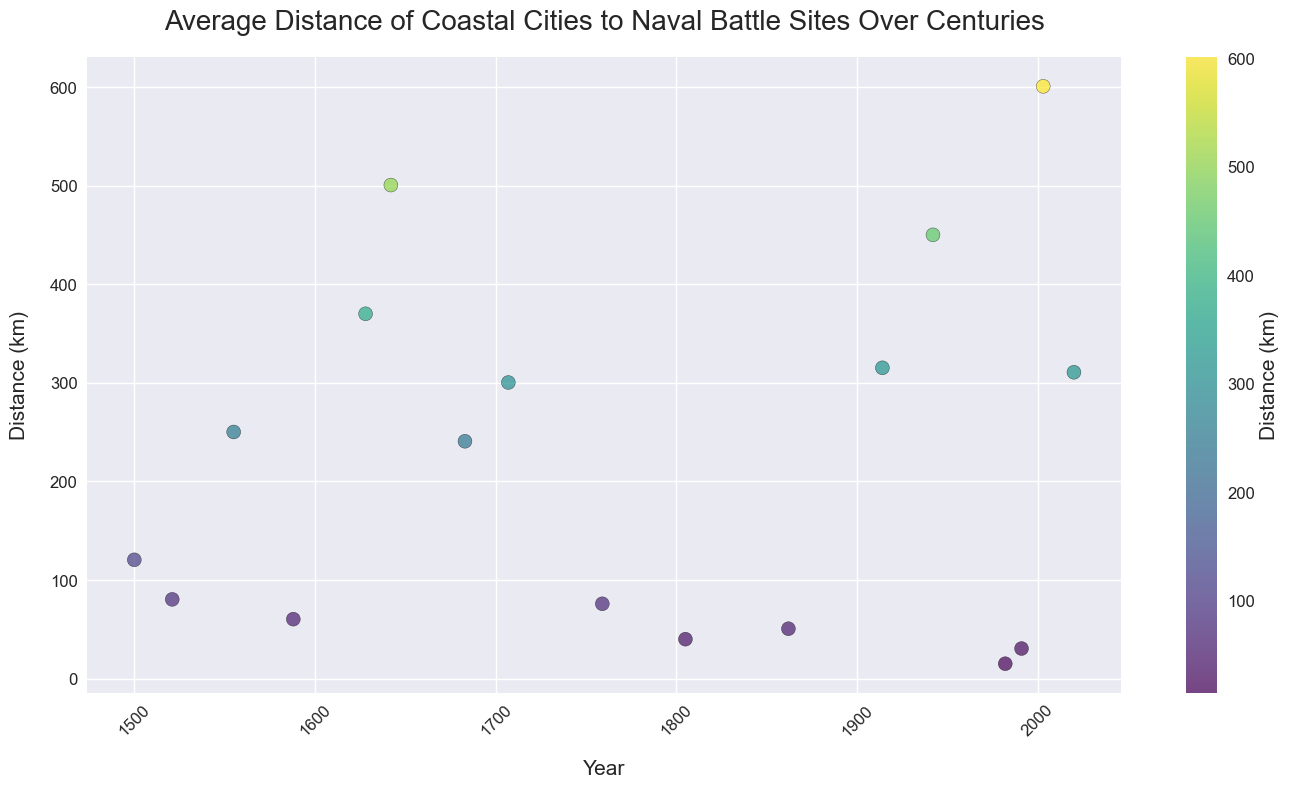Which city had the shortest distance to a naval battle site? The figure shows the average distances of various cities to naval battle sites over centuries. By observing the dots, the one closest to zero on the y-axis indicates the shortest distance. The city with the shortest distance is Port Stanley with a distance of 15.1 km.
Answer: Port Stanley Which city had the largest distance to a naval battle site? By looking at the scatter plot, the city that has the highest point on the y-axis represents the largest distance. Jakarta is the city with the largest distance, at 600.9 km.
Answer: Jakarta How did the distance of naval battle sites from coastal cities change in the 20th century? To answer this, observe the scatter points from 1900 to 1999. There are noticeable distances for Athens in 1914 (315.3 km), Sydney in 1942 (450.2 km), and Port Stanley in 1982 (15.1 km). This shows a mix of high and low distances in the 20th century.
Answer: Mixed, with both high and low distances What is the average distance of coastal cities to naval battle sites before the 18th century? To find this average, consider the distances before the year 1700: Venice (120.5 km), Barcelona (80.4 km), Lisbon (250.2 km), Plymouth (60.3 km), Stockholm (370.1 km), Madras (500.7 km). Sum these values: 120.5 + 80.4 + 250.2 + 60.3 + 370.1 + 500.7 = 1382.2. Divide by the number of cities (6), thus 1382.2 / 6 = roughly 230 km.
Answer: 230 km Did the median distance of naval battle sites from coastal cities increase or decrease after 1800? Check distances from 1801: Cadiz (40.0 km), New Orleans (50.6 km), Athens (315.3 km), Sydney (450.2 km), Port Stanley (15.1 km), Manama (30.5 km), Busan (600.9 km), Jakarta (310.8 km). Order distances: 15.1, 30.5, 40.0, 50.6, 310.8, 315.3, 450.2, 600.9. Median is the average of 4th and 5th values: (50.6 + 310.8) / 2 = 180.7 km. Comparing to values before 1800 (median 185.4 km), there is a slight decrease.
Answer: Decrease Which city had a greater distance to naval battle sites, Barcelona or New York? By observing the plot, Barcelona had a distance of 80.4 km and New York had a distance of 240.8 km. Thus, New York had a greater distance.
Answer: New York Which century shows a more consistent distance range for naval battles compared to its preceding century? We can compare the scatter points by centuries. The 18th century includes only 1 point: Marseille (300.4 km). The 19th century includes Cadiz (40.0 km) and New Orleans (50.6 km). The 19th century shows a smaller range (40.0 to 50.6 km) compared to any other prior century.
Answer: 19th century 